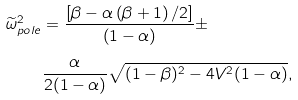Convert formula to latex. <formula><loc_0><loc_0><loc_500><loc_500>\widetilde { \omega } _ { p o l e } ^ { 2 } & = \frac { \left [ \beta - \alpha \left ( \beta + 1 \right ) / 2 \right ] } { \left ( 1 - \alpha \right ) } \pm \\ & \frac { \alpha } { 2 ( 1 - \alpha ) } \sqrt { ( 1 - \beta ) ^ { 2 } - 4 V ^ { 2 } ( 1 - \alpha ) } ,</formula> 